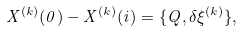Convert formula to latex. <formula><loc_0><loc_0><loc_500><loc_500>X ^ { ( k ) } ( 0 ) - X ^ { ( k ) } ( i ) = \{ Q , \delta \xi ^ { ( k ) } \} ,</formula> 